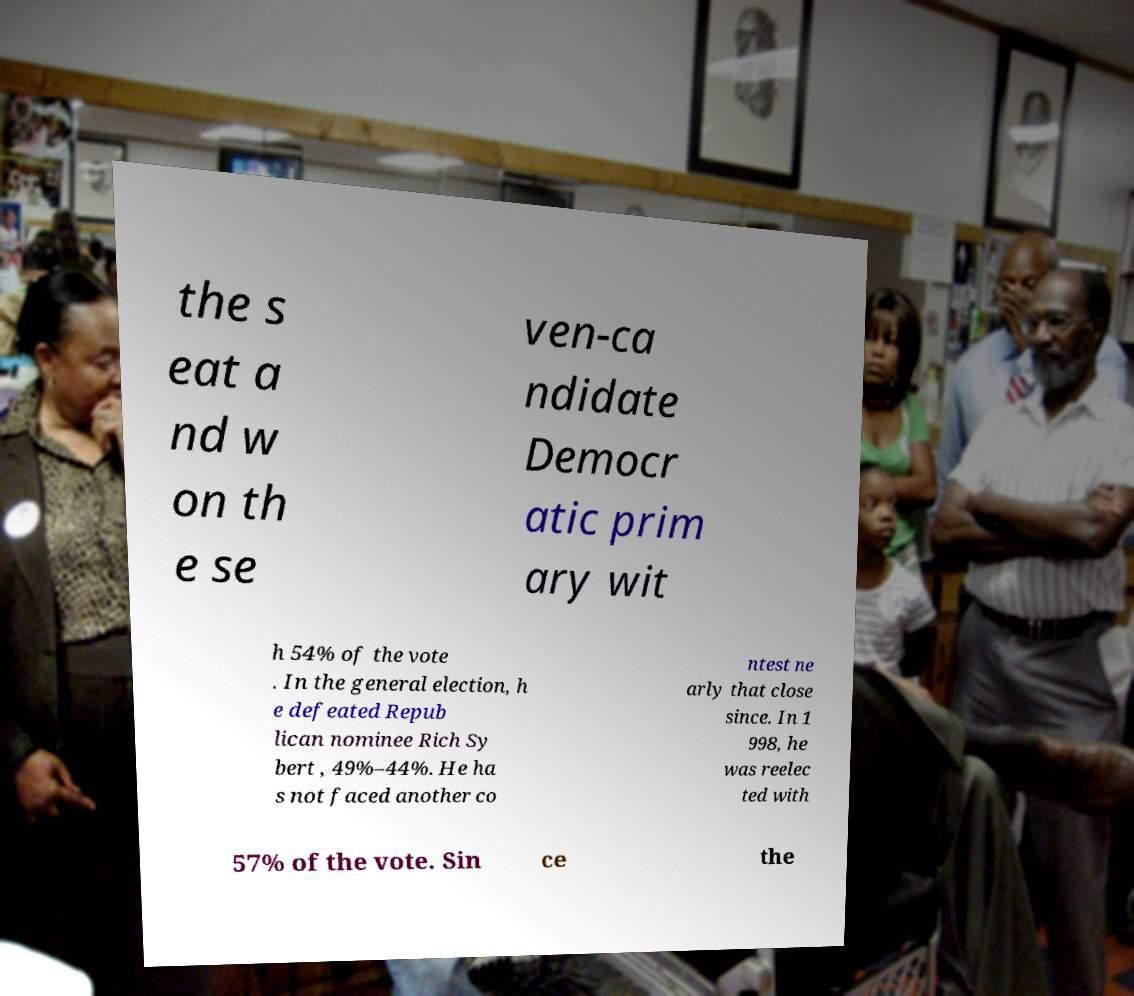For documentation purposes, I need the text within this image transcribed. Could you provide that? the s eat a nd w on th e se ven-ca ndidate Democr atic prim ary wit h 54% of the vote . In the general election, h e defeated Repub lican nominee Rich Sy bert , 49%–44%. He ha s not faced another co ntest ne arly that close since. In 1 998, he was reelec ted with 57% of the vote. Sin ce the 